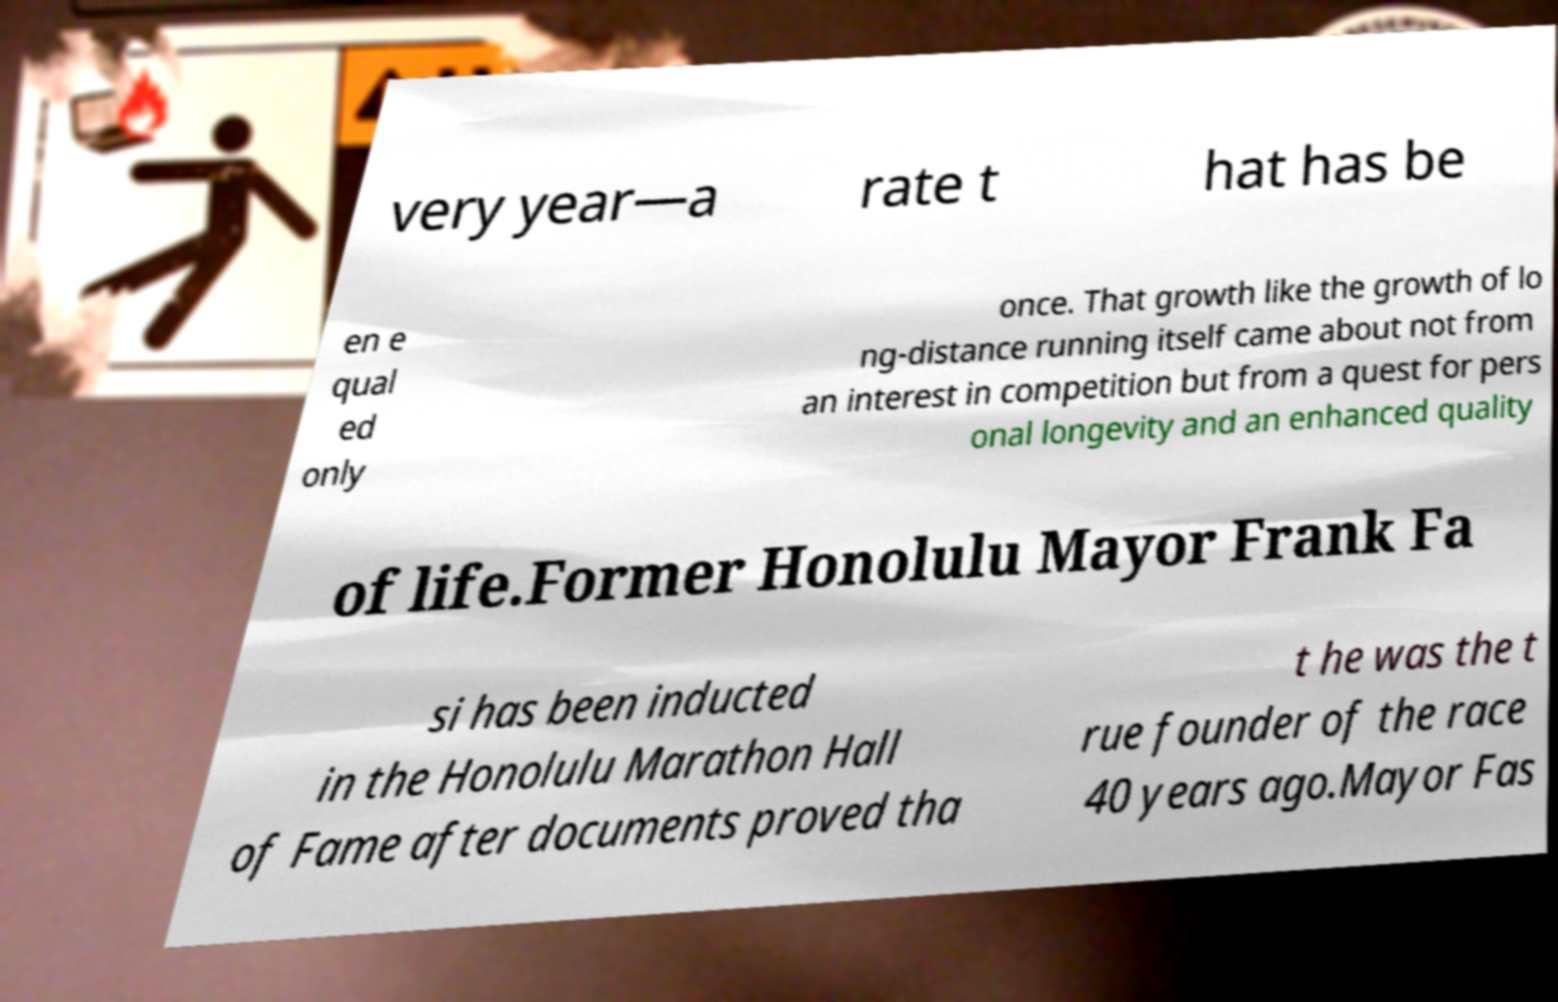There's text embedded in this image that I need extracted. Can you transcribe it verbatim? very year—a rate t hat has be en e qual ed only once. That growth like the growth of lo ng-distance running itself came about not from an interest in competition but from a quest for pers onal longevity and an enhanced quality of life.Former Honolulu Mayor Frank Fa si has been inducted in the Honolulu Marathon Hall of Fame after documents proved tha t he was the t rue founder of the race 40 years ago.Mayor Fas 